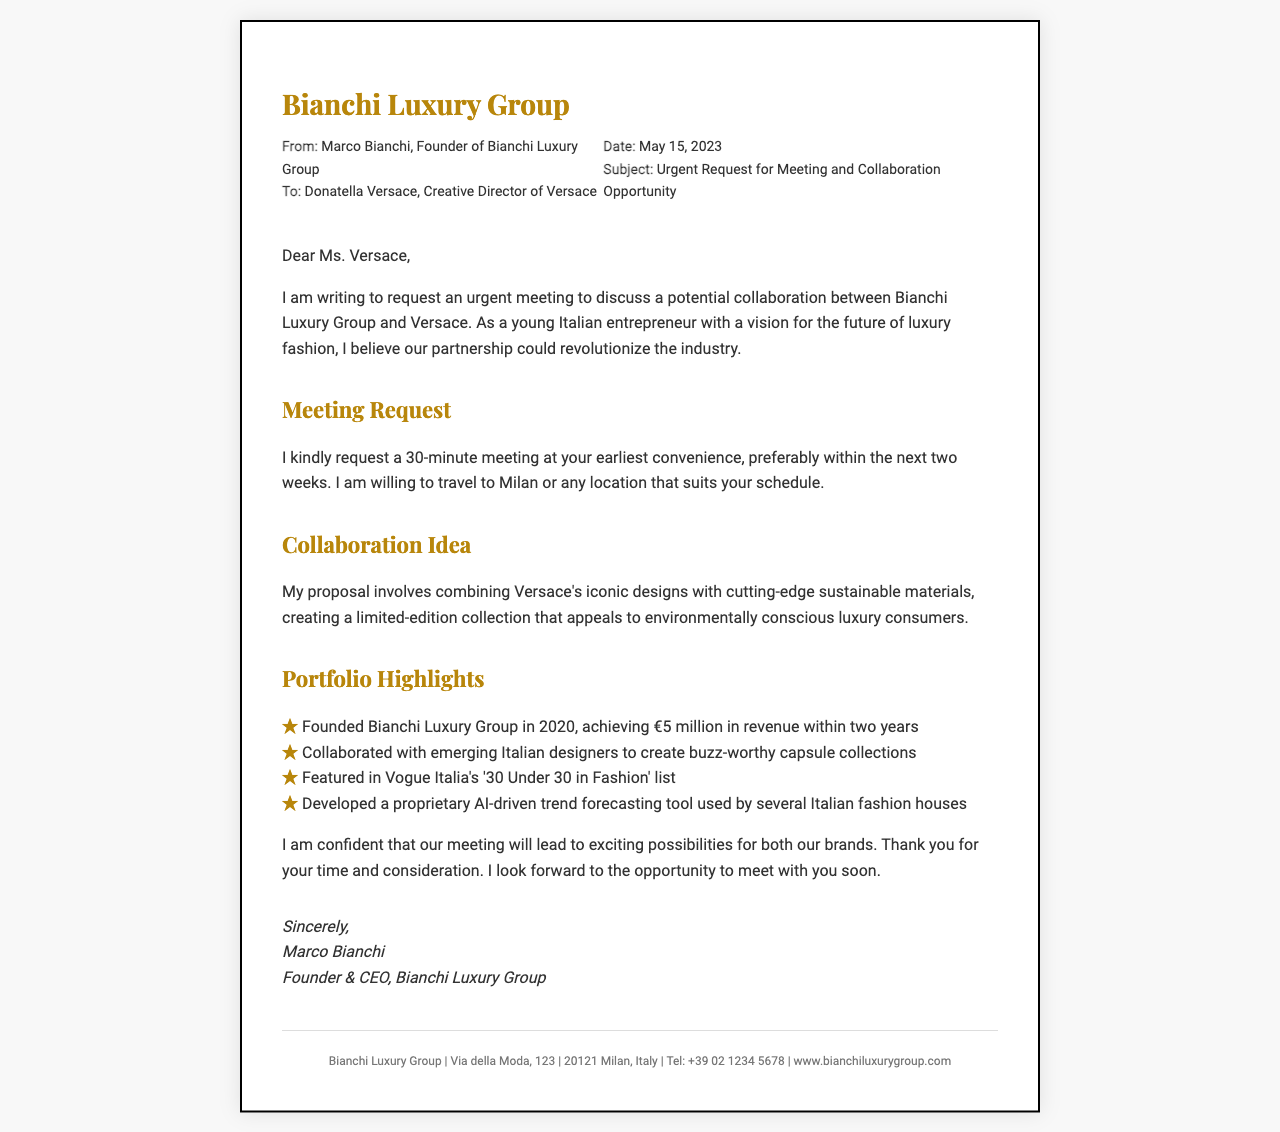who is the sender? The sender is Marco Bianchi, who is the Founder of Bianchi Luxury Group.
Answer: Marco Bianchi who is the recipient? The recipient of the fax is Donatella Versace, the Creative Director of Versace.
Answer: Donatella Versace what is the date of the request? The date mentioned in the document for the request is May 15, 2023.
Answer: May 15, 2023 what is the subject of the fax? The subject outlined in the fax refers to an urgent request for a meeting and collaboration opportunity.
Answer: Urgent Request for Meeting and Collaboration Opportunity how long is the requested meeting? The requested duration for the meeting is mentioned as 30 minutes.
Answer: 30 minutes what does the collaboration proposal involve? The collaboration proposal involves combining Versace's iconic designs with sustainable materials.
Answer: Sustainable materials how many years has Bianchi Luxury Group been established? Bianchi Luxury Group was founded in 2020, meaning it has been established for approximately three years.
Answer: 3 years what revenue has Bianchi Luxury Group achieved within two years? The revenue achieved by Bianchi Luxury Group within two years is stated as €5 million.
Answer: €5 million which notable list featured Marco Bianchi? Marco Bianchi was featured in Vogue Italia's '30 Under 30 in Fashion' list.
Answer: '30 Under 30 in Fashion' where is Bianchi Luxury Group located? The location of Bianchi Luxury Group is mentioned as Via della Moda, 123, 20121 Milan, Italy.
Answer: Via della Moda, 123, 20121 Milan, Italy 